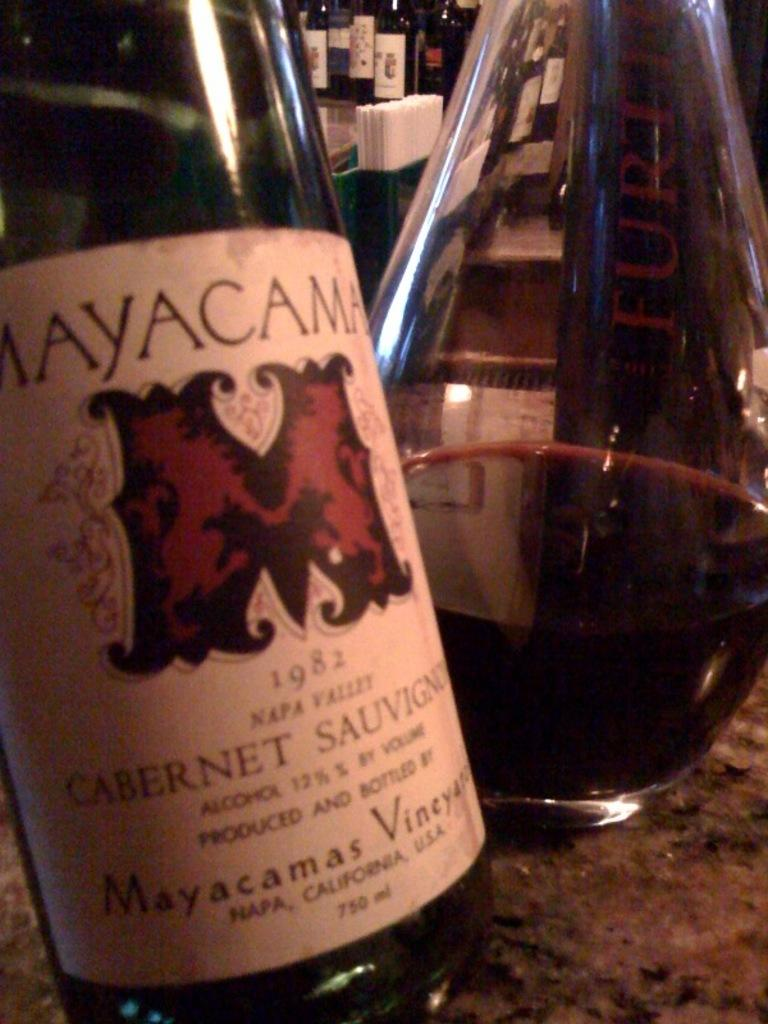<image>
Present a compact description of the photo's key features. a wine bottle with Cabernet written on the side 